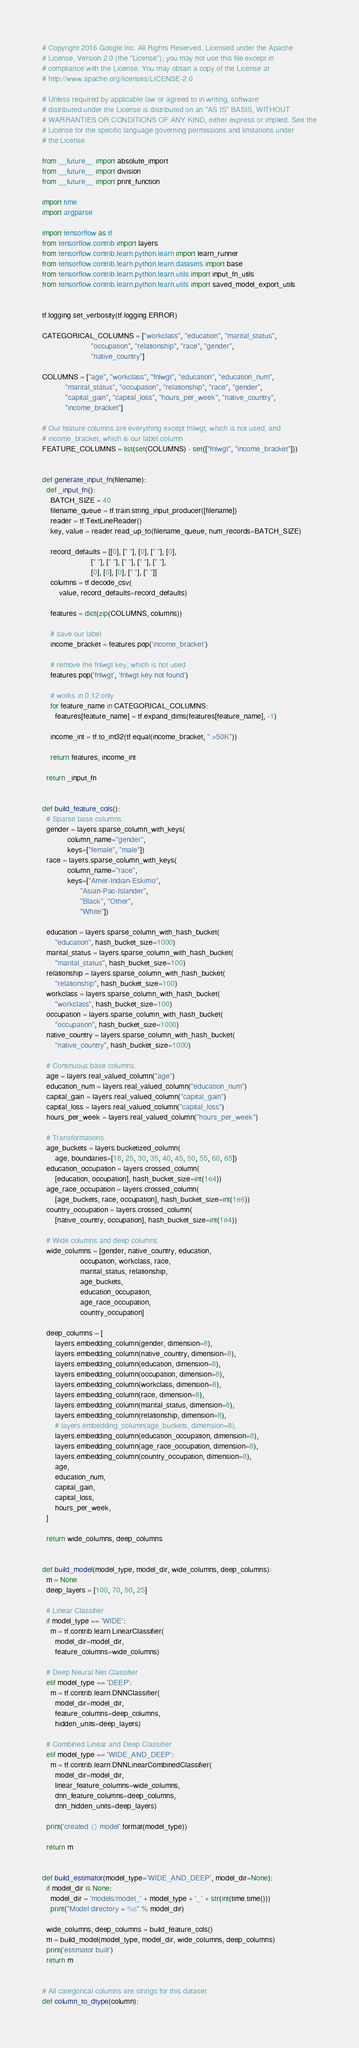<code> <loc_0><loc_0><loc_500><loc_500><_Python_># Copyright 2016 Google Inc. All Rights Reserved. Licensed under the Apache
# License, Version 2.0 (the "License"); you may not use this file except in
# compliance with the License. You may obtain a copy of the License at
# http://www.apache.org/licenses/LICENSE-2.0

# Unless required by applicable law or agreed to in writing, software
# distributed under the License is distributed on an "AS IS" BASIS, WITHOUT
# WARRANTIES OR CONDITIONS OF ANY KIND, either express or implied. See the
# License for the specific language governing permissions and limitations under
# the License.

from __future__ import absolute_import
from __future__ import division
from __future__ import print_function

import time
import argparse

import tensorflow as tf
from tensorflow.contrib import layers
from tensorflow.contrib.learn.python.learn import learn_runner
from tensorflow.contrib.learn.python.learn.datasets import base
from tensorflow.contrib.learn.python.learn.utils import input_fn_utils
from tensorflow.contrib.learn.python.learn.utils import saved_model_export_utils


tf.logging.set_verbosity(tf.logging.ERROR)

CATEGORICAL_COLUMNS = ["workclass", "education", "marital_status",
                       "occupation", "relationship", "race", "gender",
                       "native_country"]

COLUMNS = ["age", "workclass", "fnlwgt", "education", "education_num",
           "marital_status", "occupation", "relationship", "race", "gender",
           "capital_gain", "capital_loss", "hours_per_week", "native_country",
           "income_bracket"]

# Our feature columns are everything except fnlwgt, which is not used, and
# income_bracket, which is our label column
FEATURE_COLUMNS = list(set(COLUMNS) - set(["fnlwgt", "income_bracket"]))


def generate_input_fn(filename):
  def _input_fn():
    BATCH_SIZE = 40
    filename_queue = tf.train.string_input_producer([filename])
    reader = tf.TextLineReader()
    key, value = reader.read_up_to(filename_queue, num_records=BATCH_SIZE)

    record_defaults = [[0], [" "], [0], [" "], [0],
                       [" "], [" "], [" "], [" "], [" "],
                       [0], [0], [0], [" "], [" "]]
    columns = tf.decode_csv(
        value, record_defaults=record_defaults)

    features = dict(zip(COLUMNS, columns))

    # save our label
    income_bracket = features.pop('income_bracket')
    
    # remove the fnlwgt key, which is not used
    features.pop('fnlwgt', 'fnlwgt key not found')

    # works in 0.12 only
    for feature_name in CATEGORICAL_COLUMNS:
      features[feature_name] = tf.expand_dims(features[feature_name], -1)

    income_int = tf.to_int32(tf.equal(income_bracket, " >50K"))

    return features, income_int

  return _input_fn


def build_feature_cols():
  # Sparse base columns.
  gender = layers.sparse_column_with_keys(
            column_name="gender",
            keys=["female", "male"])
  race = layers.sparse_column_with_keys(
            column_name="race",
            keys=["Amer-Indian-Eskimo",
                  "Asian-Pac-Islander",
                  "Black", "Other",
                  "White"])

  education = layers.sparse_column_with_hash_bucket(
      "education", hash_bucket_size=1000)
  marital_status = layers.sparse_column_with_hash_bucket(
      "marital_status", hash_bucket_size=100)
  relationship = layers.sparse_column_with_hash_bucket(
      "relationship", hash_bucket_size=100)
  workclass = layers.sparse_column_with_hash_bucket(
      "workclass", hash_bucket_size=100)
  occupation = layers.sparse_column_with_hash_bucket(
      "occupation", hash_bucket_size=1000)
  native_country = layers.sparse_column_with_hash_bucket(
      "native_country", hash_bucket_size=1000)

  # Continuous base columns.
  age = layers.real_valued_column("age")
  education_num = layers.real_valued_column("education_num")
  capital_gain = layers.real_valued_column("capital_gain")
  capital_loss = layers.real_valued_column("capital_loss")
  hours_per_week = layers.real_valued_column("hours_per_week")

  # Transformations.
  age_buckets = layers.bucketized_column(
      age, boundaries=[18, 25, 30, 35, 40, 45, 50, 55, 60, 65])
  education_occupation = layers.crossed_column(
      [education, occupation], hash_bucket_size=int(1e4))
  age_race_occupation = layers.crossed_column(
      [age_buckets, race, occupation], hash_bucket_size=int(1e6))
  country_occupation = layers.crossed_column(
      [native_country, occupation], hash_bucket_size=int(1e4))

  # Wide columns and deep columns.
  wide_columns = [gender, native_country, education, 
                  occupation, workclass, race, 
                  marital_status, relationship, 
                  age_buckets,
                  education_occupation, 
                  age_race_occupation,
                  country_occupation]

  deep_columns = [
      layers.embedding_column(gender, dimension=8),
      layers.embedding_column(native_country, dimension=8),
      layers.embedding_column(education, dimension=8),
      layers.embedding_column(occupation, dimension=8),
      layers.embedding_column(workclass, dimension=8),
      layers.embedding_column(race, dimension=8),
      layers.embedding_column(marital_status, dimension=8),
      layers.embedding_column(relationship, dimension=8),
      # layers.embedding_column(age_buckets, dimension=8),
      layers.embedding_column(education_occupation, dimension=8),
      layers.embedding_column(age_race_occupation, dimension=8),
      layers.embedding_column(country_occupation, dimension=8),
      age,
      education_num,
      capital_gain,
      capital_loss,
      hours_per_week,
  ]

  return wide_columns, deep_columns


def build_model(model_type, model_dir, wide_columns, deep_columns):
  m = None
  deep_layers = [100, 70, 50, 25]

  # Linear Classifier
  if model_type == 'WIDE':
    m = tf.contrib.learn.LinearClassifier(
      model_dir=model_dir, 
      feature_columns=wide_columns)

  # Deep Neural Net Classifier
  elif model_type == 'DEEP':
    m = tf.contrib.learn.DNNClassifier(
      model_dir=model_dir,
      feature_columns=deep_columns,
      hidden_units=deep_layers)

  # Combined Linear and Deep Classifier
  elif model_type == 'WIDE_AND_DEEP':
    m = tf.contrib.learn.DNNLinearCombinedClassifier(
      model_dir=model_dir,
      linear_feature_columns=wide_columns,
      dnn_feature_columns=deep_columns,
      dnn_hidden_units=deep_layers)

  print('created {} model'.format(model_type))

  return m


def build_estimator(model_type='WIDE_AND_DEEP', model_dir=None):
  if model_dir is None:
    model_dir = 'models/model_' + model_type + '_' + str(int(time.time()))
    print("Model directory = %s" % model_dir)

  wide_columns, deep_columns = build_feature_cols()
  m = build_model(model_type, model_dir, wide_columns, deep_columns)
  print('estimator built')
  return m


# All categorical columns are strings for this dataset
def column_to_dtype(column):</code> 